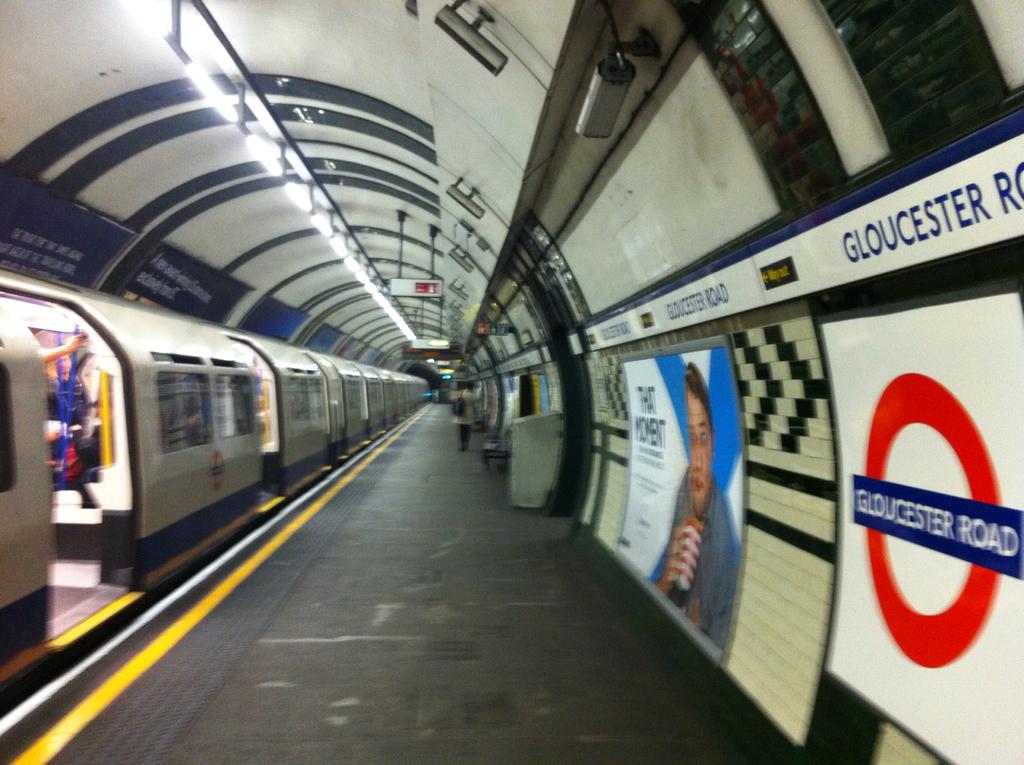What does it say in the red ring?
Ensure brevity in your answer.  Gloucester road. What are the first two words of the advertisement towards the middle?
Provide a succinct answer. That moment. 